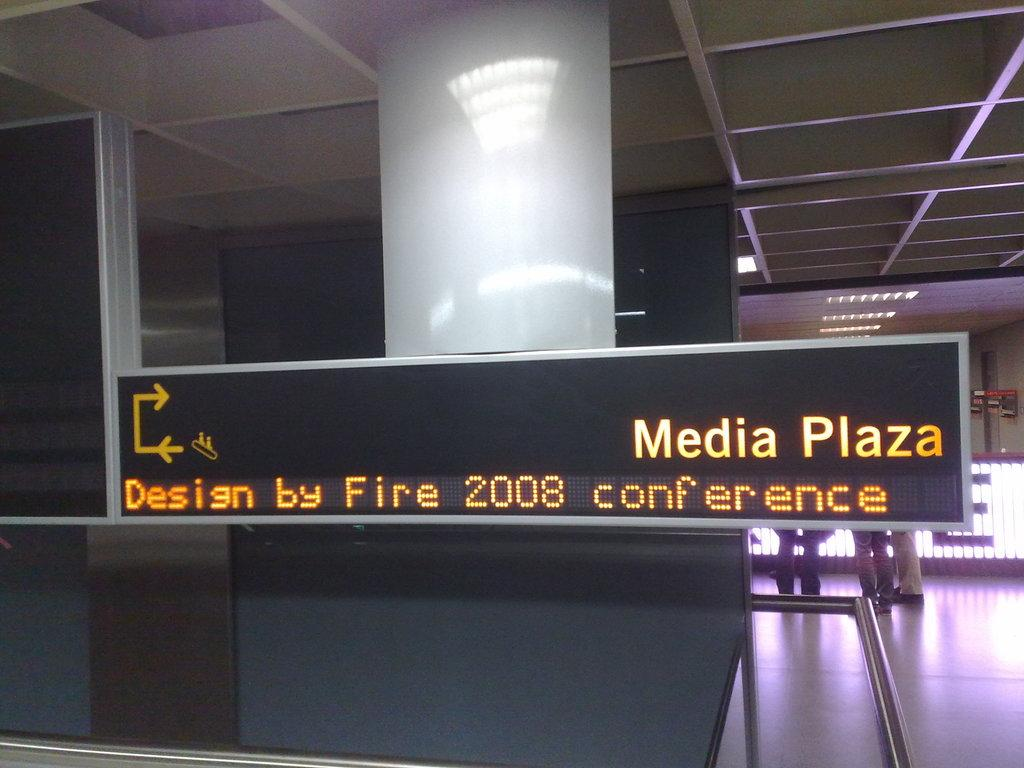<image>
Create a compact narrative representing the image presented. a digital sign inside of a building that says 'media plaza' on it 